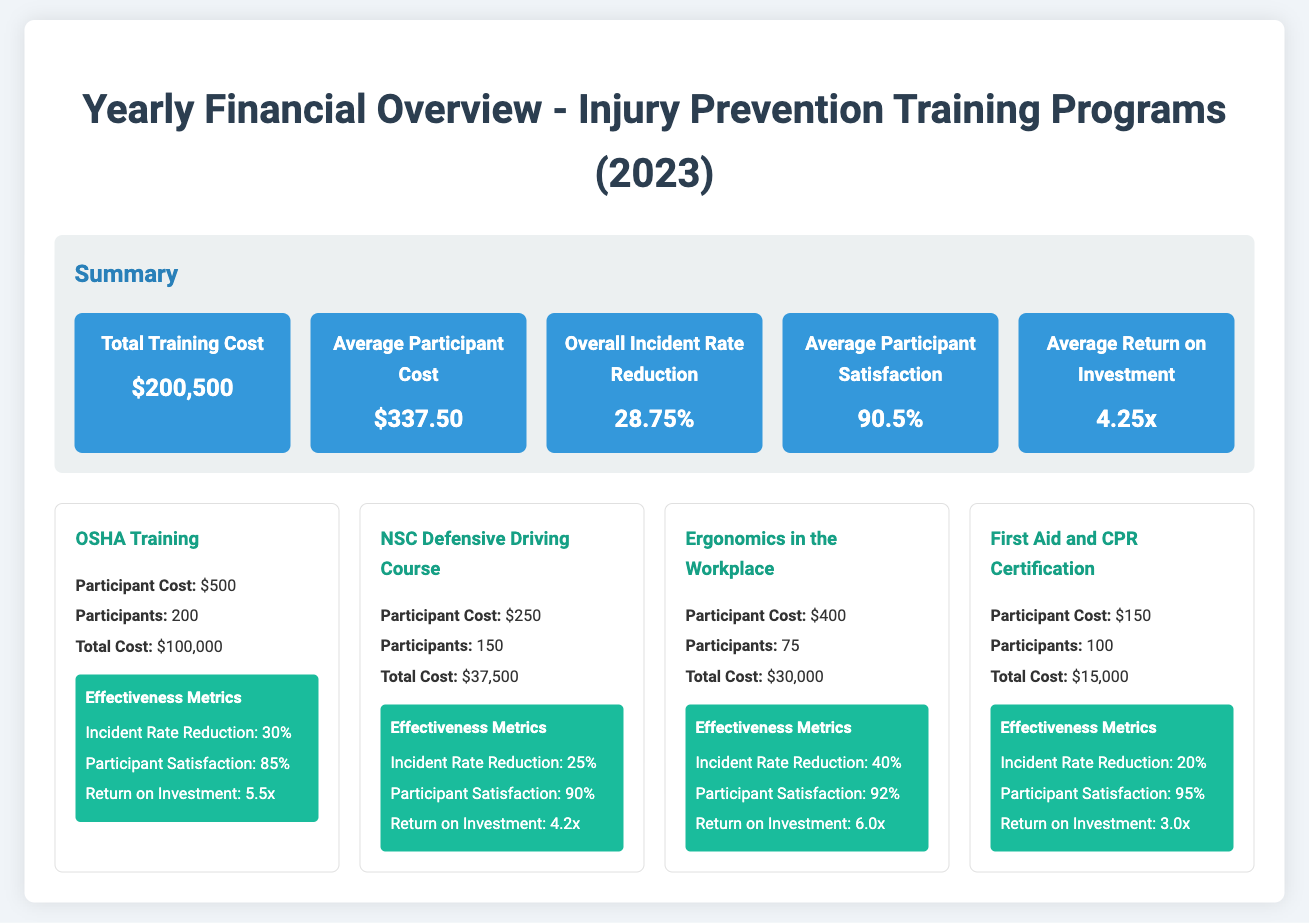what is the total training cost? The total training cost is stated clearly in the summary portion of the document.
Answer: $200,500 what is the average participant cost? The average participant cost can be found in the summary section of the report.
Answer: $337.50 what is the overall incident rate reduction? The overall incident rate reduction is part of the summary information provided in the document.
Answer: 28.75% which program has the highest participant satisfaction? By comparing the participant satisfaction metrics of each program, we can identify the one with the highest score.
Answer: First Aid and CPR Certification what is the participant cost for the Ergonomics in the Workplace program? The participant cost for the Ergonomics in the Workplace program is listed in its specific details.
Answer: $400 what is the return on investment for the OSHA Training program? The return on investment is included in the effectiveness metrics for each program, specifically for OSHA Training.
Answer: 5.5x how many participants were involved in the NSC Defensive Driving Course? The number of participants is clearly stated in the program's details.
Answer: 150 which training program had the lowest total cost? By analyzing the total costs of each training program, we can determine which one is the lowest.
Answer: First Aid and CPR Certification what is the average return on investment across all programs? The average return on investment is found in the summary section, combining the effectiveness of all programs.
Answer: 4.25x 